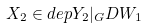Convert formula to latex. <formula><loc_0><loc_0><loc_500><loc_500>X _ { 2 } \in d e p Y _ { 2 } | _ { G } D W _ { 1 }</formula> 